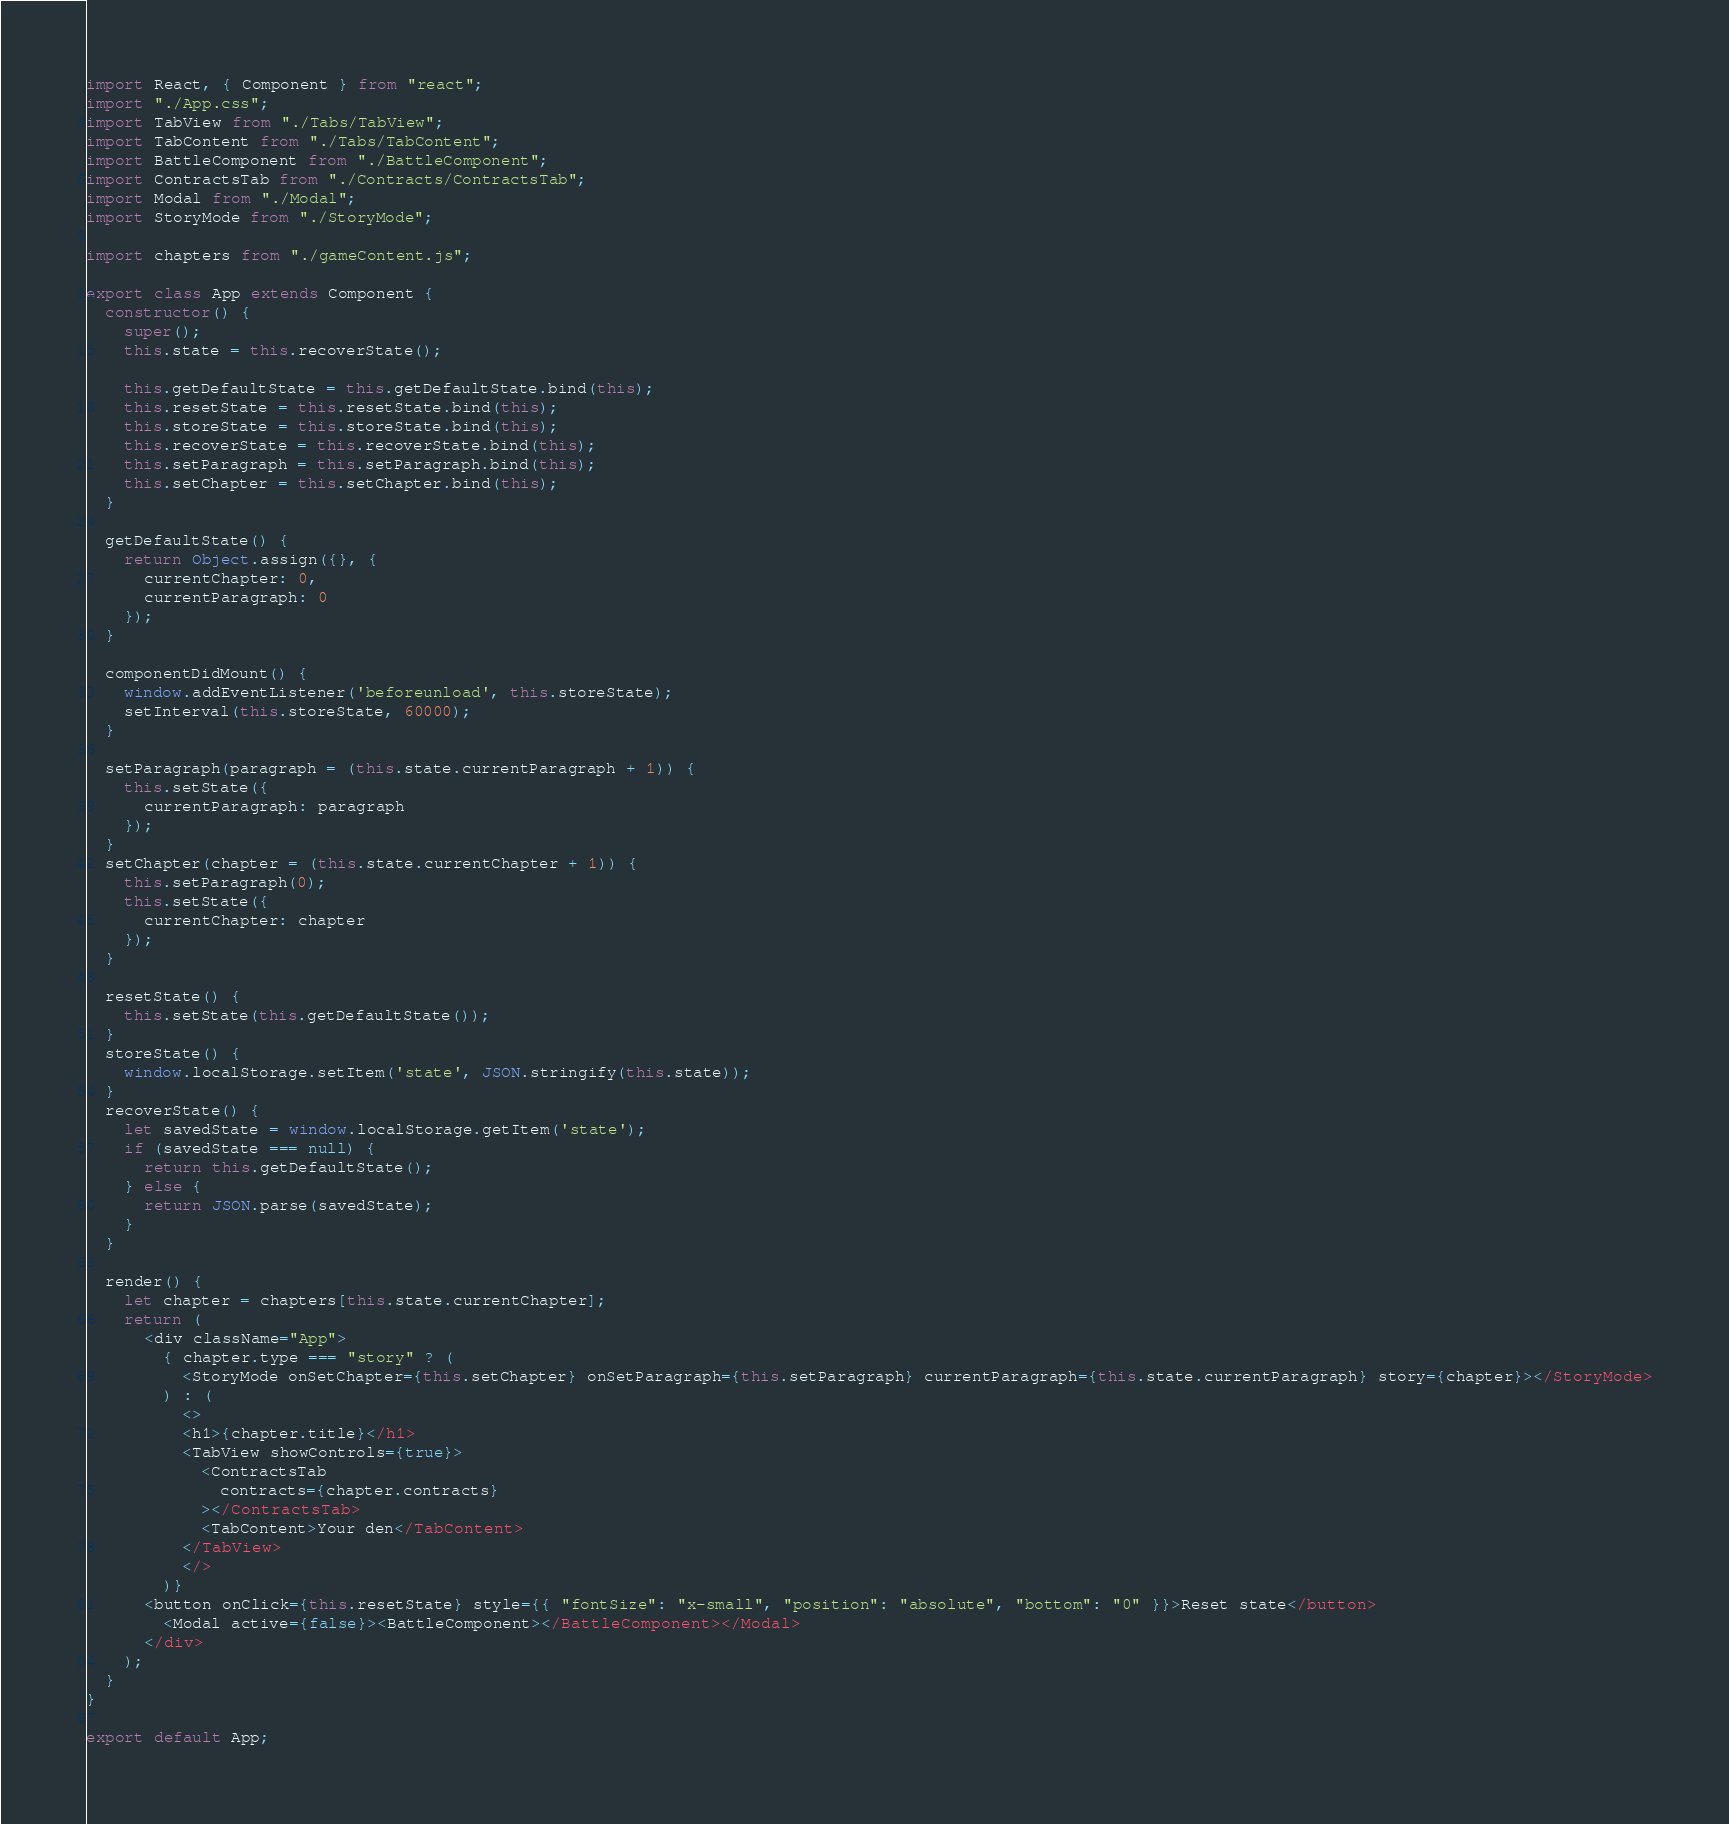<code> <loc_0><loc_0><loc_500><loc_500><_JavaScript_>import React, { Component } from "react";
import "./App.css";
import TabView from "./Tabs/TabView";
import TabContent from "./Tabs/TabContent";
import BattleComponent from "./BattleComponent";
import ContractsTab from "./Contracts/ContractsTab";
import Modal from "./Modal";
import StoryMode from "./StoryMode";

import chapters from "./gameContent.js";

export class App extends Component {
  constructor() {
    super();
    this.state = this.recoverState();

    this.getDefaultState = this.getDefaultState.bind(this);
    this.resetState = this.resetState.bind(this);
    this.storeState = this.storeState.bind(this);
    this.recoverState = this.recoverState.bind(this);
    this.setParagraph = this.setParagraph.bind(this);
    this.setChapter = this.setChapter.bind(this);
  }

  getDefaultState() {
    return Object.assign({}, {
      currentChapter: 0,
      currentParagraph: 0
    });
  }

  componentDidMount() {
    window.addEventListener('beforeunload', this.storeState);
    setInterval(this.storeState, 60000);
  }

  setParagraph(paragraph = (this.state.currentParagraph + 1)) {
    this.setState({
      currentParagraph: paragraph
    });
  }
  setChapter(chapter = (this.state.currentChapter + 1)) {
    this.setParagraph(0);
    this.setState({
      currentChapter: chapter
    });
  }

  resetState() {
    this.setState(this.getDefaultState());
  }
  storeState() {
    window.localStorage.setItem('state', JSON.stringify(this.state));
  }
  recoverState() {
    let savedState = window.localStorage.getItem('state');
    if (savedState === null) {
      return this.getDefaultState();
    } else {
      return JSON.parse(savedState);
    }
  }

  render() {
    let chapter = chapters[this.state.currentChapter];
    return (
      <div className="App">
        { chapter.type === "story" ? (
          <StoryMode onSetChapter={this.setChapter} onSetParagraph={this.setParagraph} currentParagraph={this.state.currentParagraph} story={chapter}></StoryMode>
        ) : (
          <>
          <h1>{chapter.title}</h1>
          <TabView showControls={true}>
            <ContractsTab
              contracts={chapter.contracts}
            ></ContractsTab>
            <TabContent>Your den</TabContent>
          </TabView>
          </>
        )}
      <button onClick={this.resetState} style={{ "fontSize": "x-small", "position": "absolute", "bottom": "0" }}>Reset state</button>
        <Modal active={false}><BattleComponent></BattleComponent></Modal>
      </div>
    );
  }
}

export default App;
</code> 